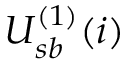Convert formula to latex. <formula><loc_0><loc_0><loc_500><loc_500>U _ { s b } ^ { ( 1 ) } ( i )</formula> 